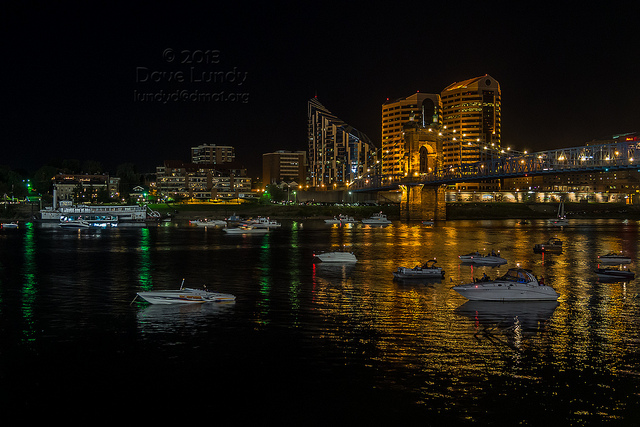<image>Who took this photo? It is unknown who took this photo. It could be anyone from a photographer, a ship captain to Dave Lundy. Who took this photo? I don't know who took this photo. It could be a photographer, a human, someone, a man, a ship captain, or Dave Lundy. 